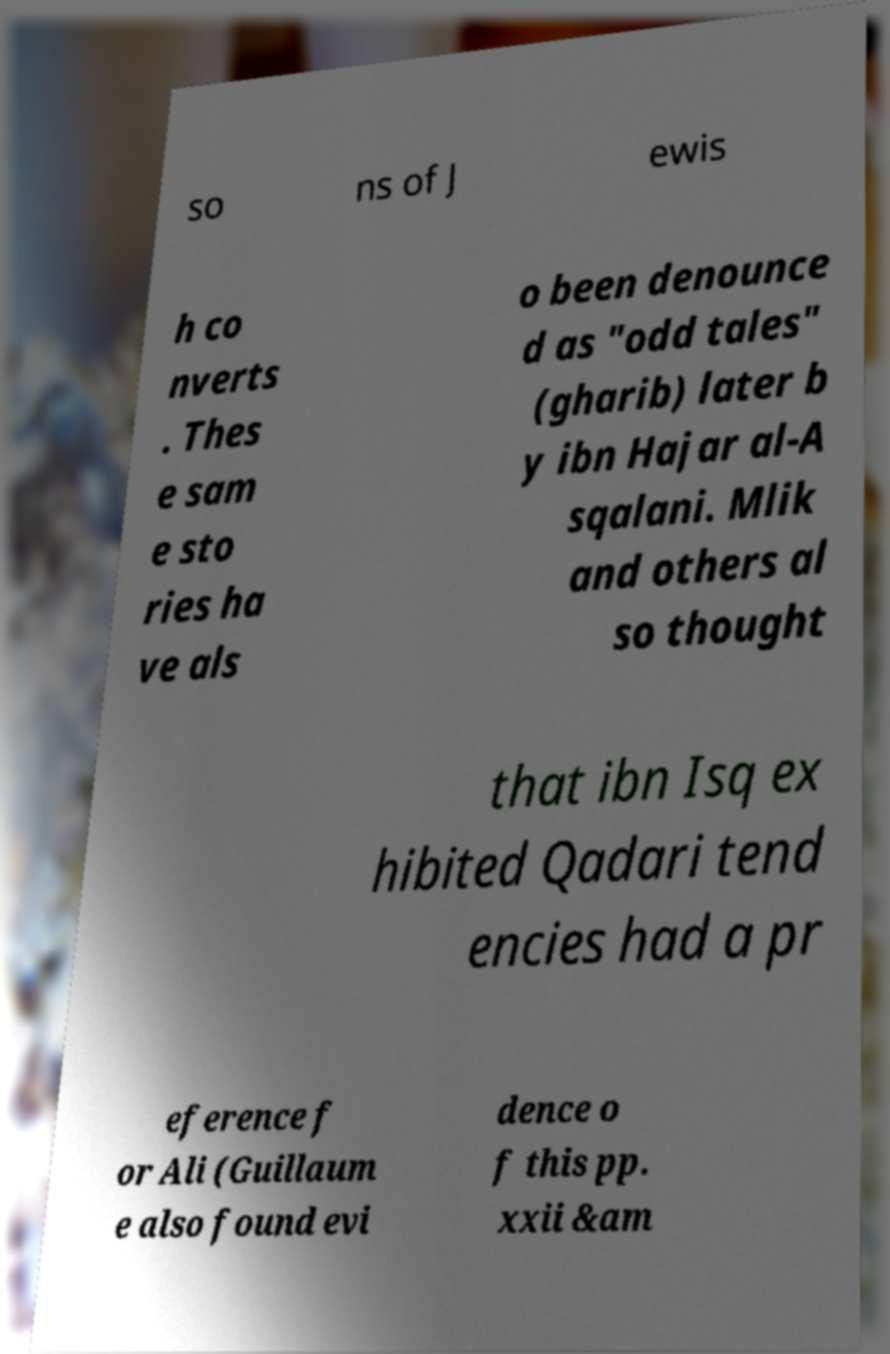Could you assist in decoding the text presented in this image and type it out clearly? so ns of J ewis h co nverts . Thes e sam e sto ries ha ve als o been denounce d as "odd tales" (gharib) later b y ibn Hajar al-A sqalani. Mlik and others al so thought that ibn Isq ex hibited Qadari tend encies had a pr eference f or Ali (Guillaum e also found evi dence o f this pp. xxii &am 